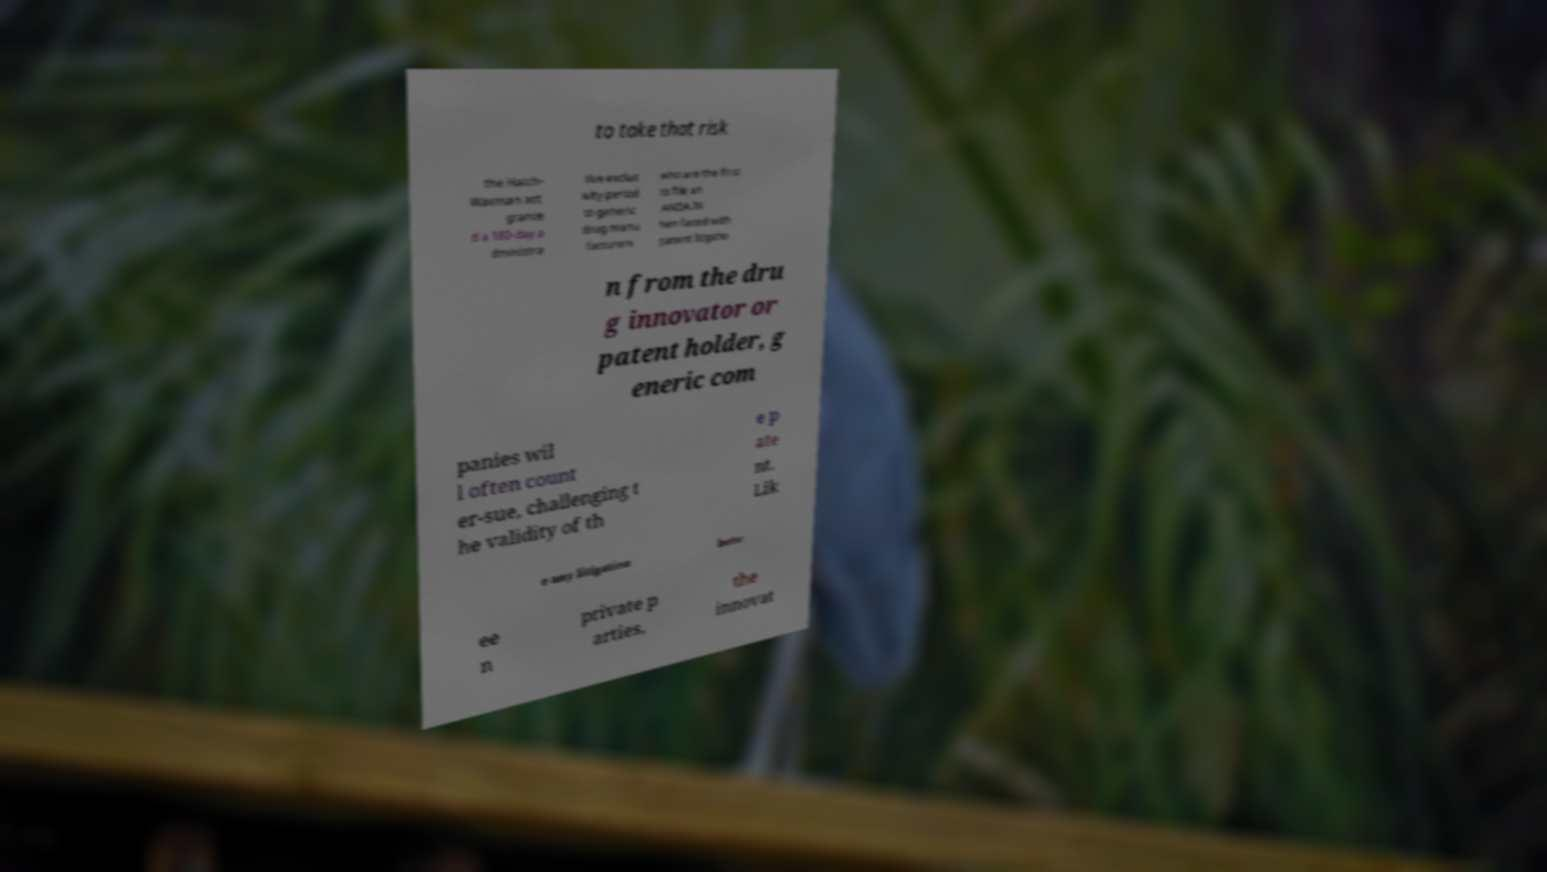Could you extract and type out the text from this image? to take that risk the Hatch- Waxman act grante d a 180-day a dministra tive exclus ivity period to generic drug manu facturers who are the first to file an ANDA.W hen faced with patent litigatio n from the dru g innovator or patent holder, g eneric com panies wil l often count er-sue, challenging t he validity of th e p ate nt. Lik e any litigation betw ee n private p arties, the innovat 